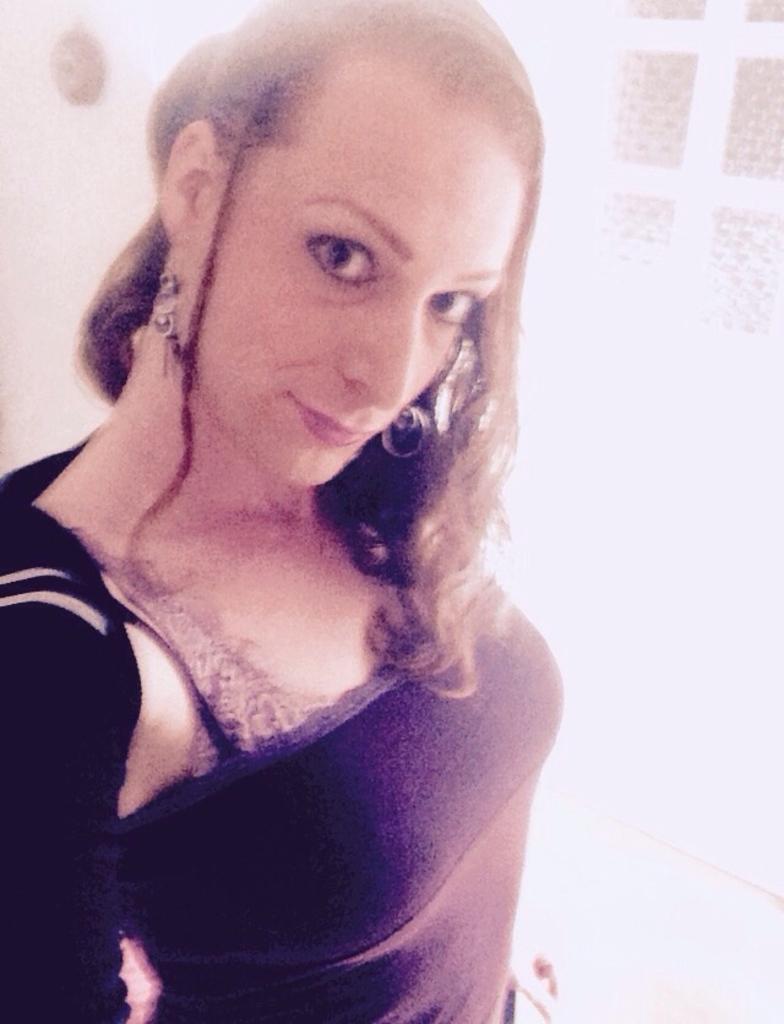Could you give a brief overview of what you see in this image? A picture of a woman. Background it is in white color. 